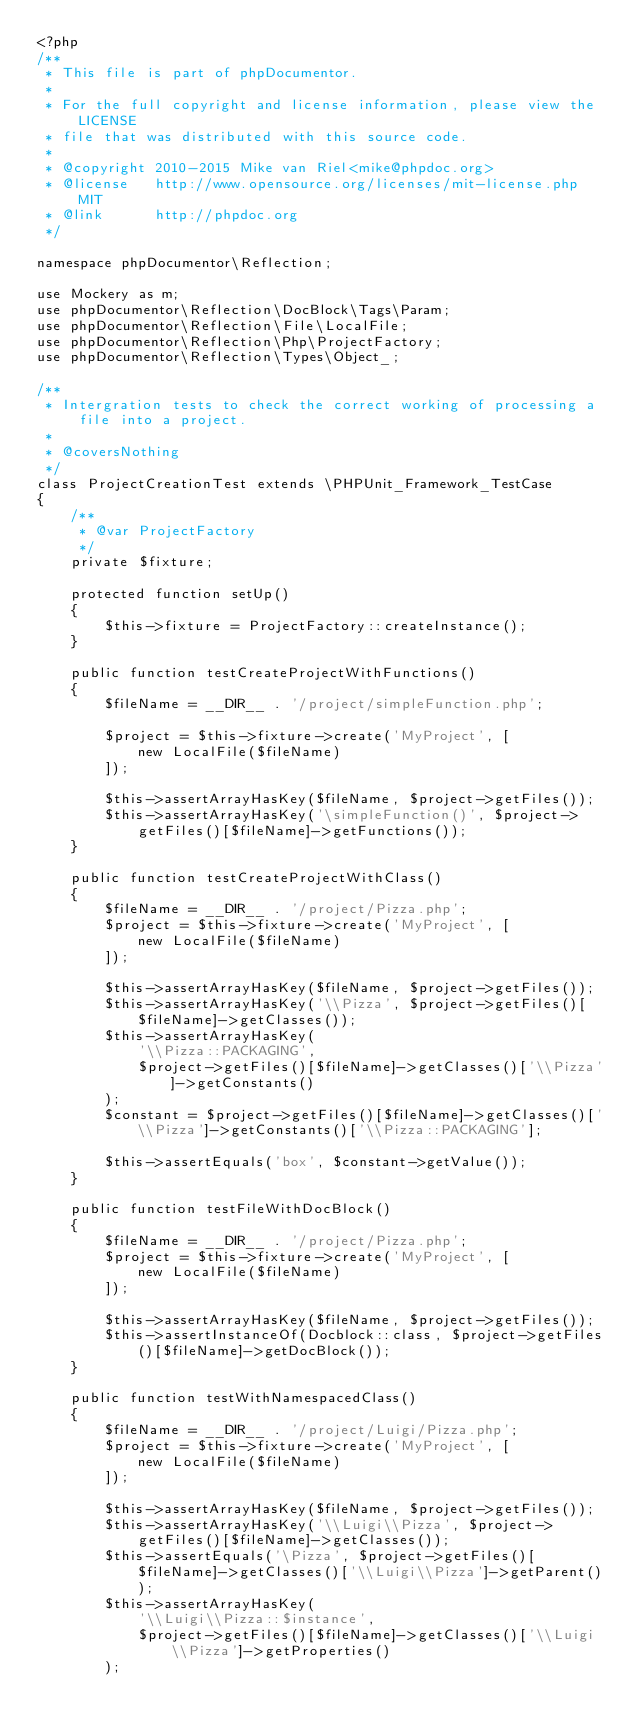<code> <loc_0><loc_0><loc_500><loc_500><_PHP_><?php
/**
 * This file is part of phpDocumentor.
 *
 * For the full copyright and license information, please view the LICENSE
 * file that was distributed with this source code.
 *
 * @copyright 2010-2015 Mike van Riel<mike@phpdoc.org>
 * @license   http://www.opensource.org/licenses/mit-license.php MIT
 * @link      http://phpdoc.org
 */

namespace phpDocumentor\Reflection;

use Mockery as m;
use phpDocumentor\Reflection\DocBlock\Tags\Param;
use phpDocumentor\Reflection\File\LocalFile;
use phpDocumentor\Reflection\Php\ProjectFactory;
use phpDocumentor\Reflection\Types\Object_;

/**
 * Intergration tests to check the correct working of processing a file into a project.
 *
 * @coversNothing
 */
class ProjectCreationTest extends \PHPUnit_Framework_TestCase
{
    /**
     * @var ProjectFactory
     */
    private $fixture;

    protected function setUp()
    {
        $this->fixture = ProjectFactory::createInstance();
    }

    public function testCreateProjectWithFunctions()
    {
        $fileName = __DIR__ . '/project/simpleFunction.php';

        $project = $this->fixture->create('MyProject', [
            new LocalFile($fileName)
        ]);

        $this->assertArrayHasKey($fileName, $project->getFiles());
        $this->assertArrayHasKey('\simpleFunction()', $project->getFiles()[$fileName]->getFunctions());
    }

    public function testCreateProjectWithClass()
    {
        $fileName = __DIR__ . '/project/Pizza.php';
        $project = $this->fixture->create('MyProject', [
            new LocalFile($fileName)
        ]);

        $this->assertArrayHasKey($fileName, $project->getFiles());
        $this->assertArrayHasKey('\\Pizza', $project->getFiles()[$fileName]->getClasses());
        $this->assertArrayHasKey(
            '\\Pizza::PACKAGING',
            $project->getFiles()[$fileName]->getClasses()['\\Pizza']->getConstants()
        );
        $constant = $project->getFiles()[$fileName]->getClasses()['\\Pizza']->getConstants()['\\Pizza::PACKAGING'];

        $this->assertEquals('box', $constant->getValue());
    }

    public function testFileWithDocBlock()
    {
        $fileName = __DIR__ . '/project/Pizza.php';
        $project = $this->fixture->create('MyProject', [
            new LocalFile($fileName)
        ]);

        $this->assertArrayHasKey($fileName, $project->getFiles());
        $this->assertInstanceOf(Docblock::class, $project->getFiles()[$fileName]->getDocBlock());
    }

    public function testWithNamespacedClass()
    {
        $fileName = __DIR__ . '/project/Luigi/Pizza.php';
        $project = $this->fixture->create('MyProject', [
            new LocalFile($fileName)
        ]);

        $this->assertArrayHasKey($fileName, $project->getFiles());
        $this->assertArrayHasKey('\\Luigi\\Pizza', $project->getFiles()[$fileName]->getClasses());
        $this->assertEquals('\Pizza', $project->getFiles()[$fileName]->getClasses()['\\Luigi\\Pizza']->getParent());
        $this->assertArrayHasKey(
            '\\Luigi\\Pizza::$instance',
            $project->getFiles()[$fileName]->getClasses()['\\Luigi\\Pizza']->getProperties()
        );
</code> 